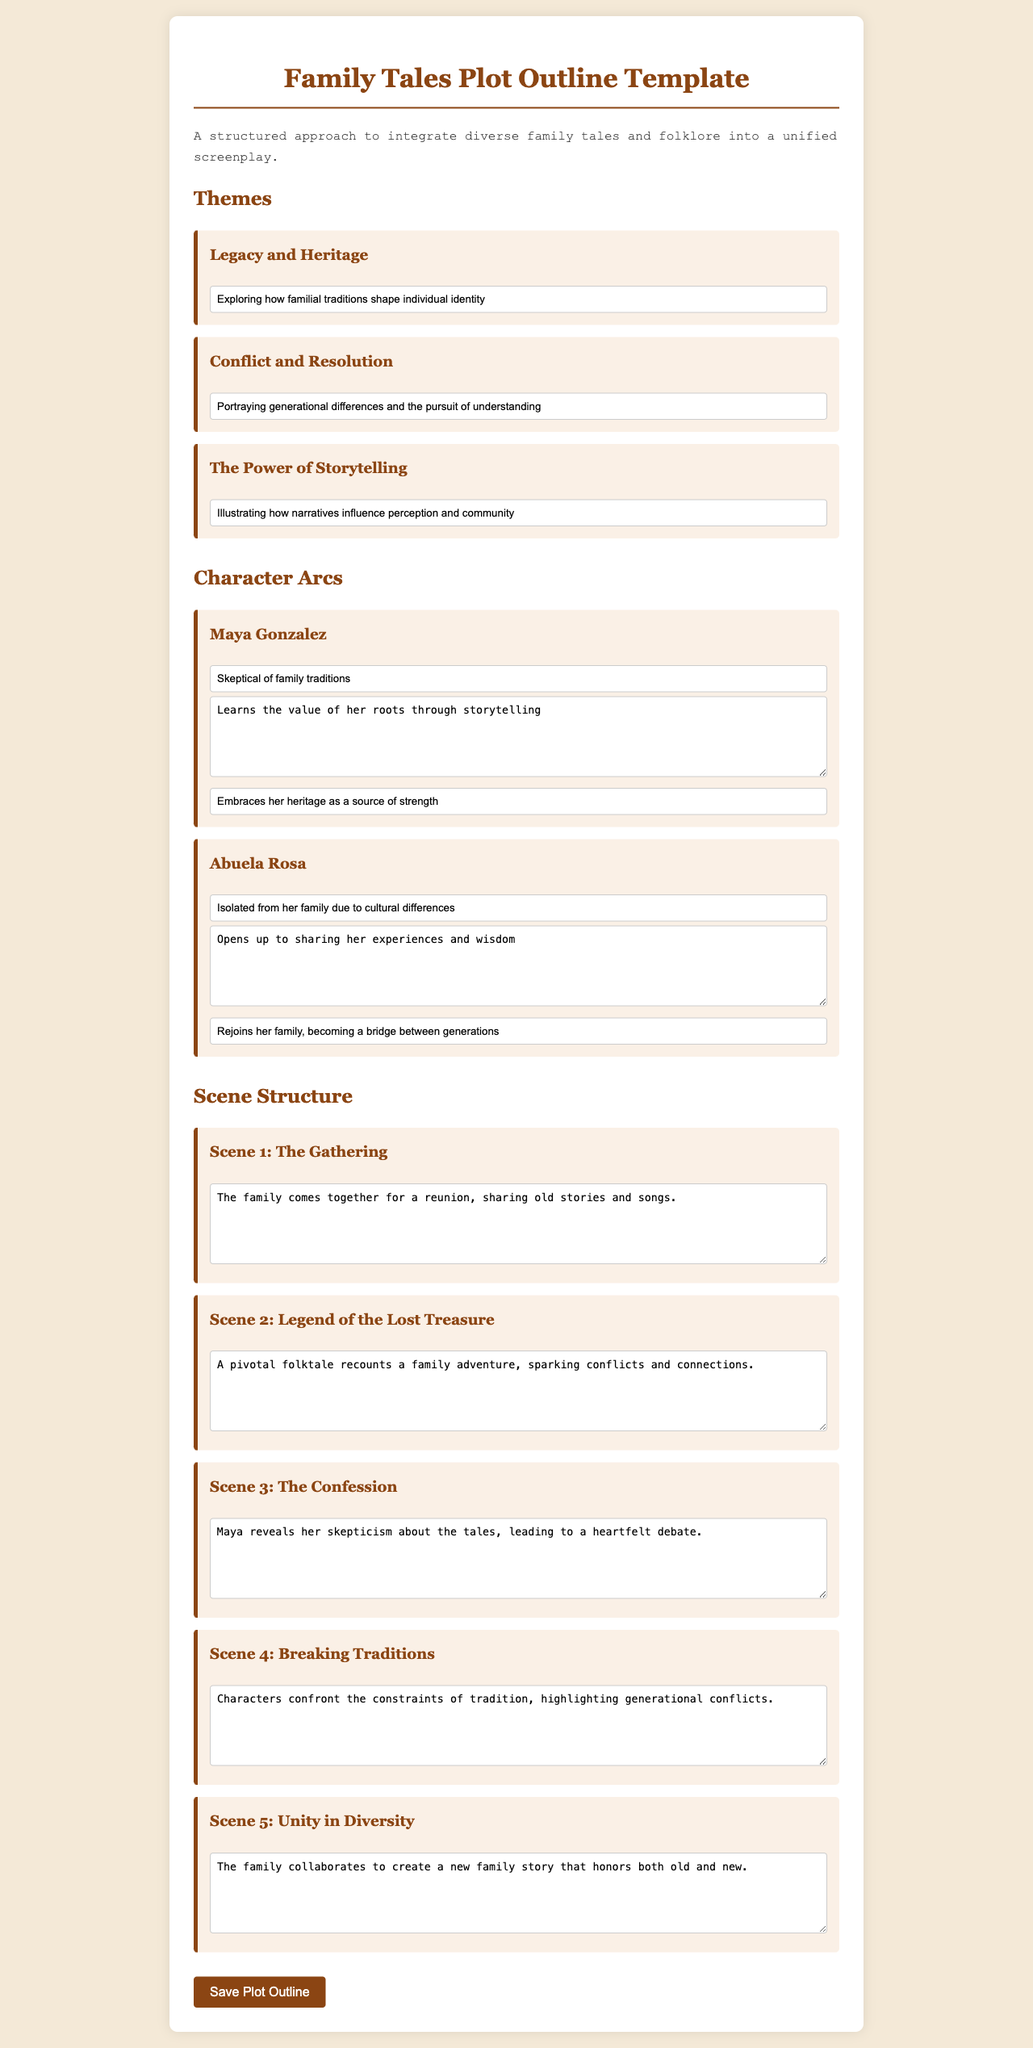What are the three main themes? The document lists three themes under "Themes": Legacy and Heritage, Conflict and Resolution, The Power of Storytelling.
Answer: Legacy and Heritage, Conflict and Resolution, The Power of Storytelling Who is the character that learns the value of her roots? The character arc describes Maya Gonzalez as the one who learns the value of her roots through storytelling.
Answer: Maya Gonzalez What does Abuela Rosa become at the end of her arc? The document states that Abuela Rosa re-joins her family and becomes a bridge between generations at the end of her character arc.
Answer: A bridge between generations What is the scene about the family reunion? The first scene described involves the family coming together to share stories and songs during a reunion.
Answer: The family comes together for a reunion, sharing old stories and songs What pivotal event does the legend of the lost treasure trigger? The scene about the "Legend of the Lost Treasure" recounts a family adventure, which sparks conflicts and connections between characters.
Answer: Conflicts and connections 